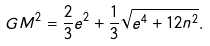<formula> <loc_0><loc_0><loc_500><loc_500>G M ^ { 2 } = \frac { 2 } { 3 } e ^ { 2 } + \frac { 1 } { 3 } \sqrt { e ^ { 4 } + 1 2 n ^ { 2 } } .</formula> 